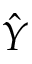Convert formula to latex. <formula><loc_0><loc_0><loc_500><loc_500>\hat { Y }</formula> 